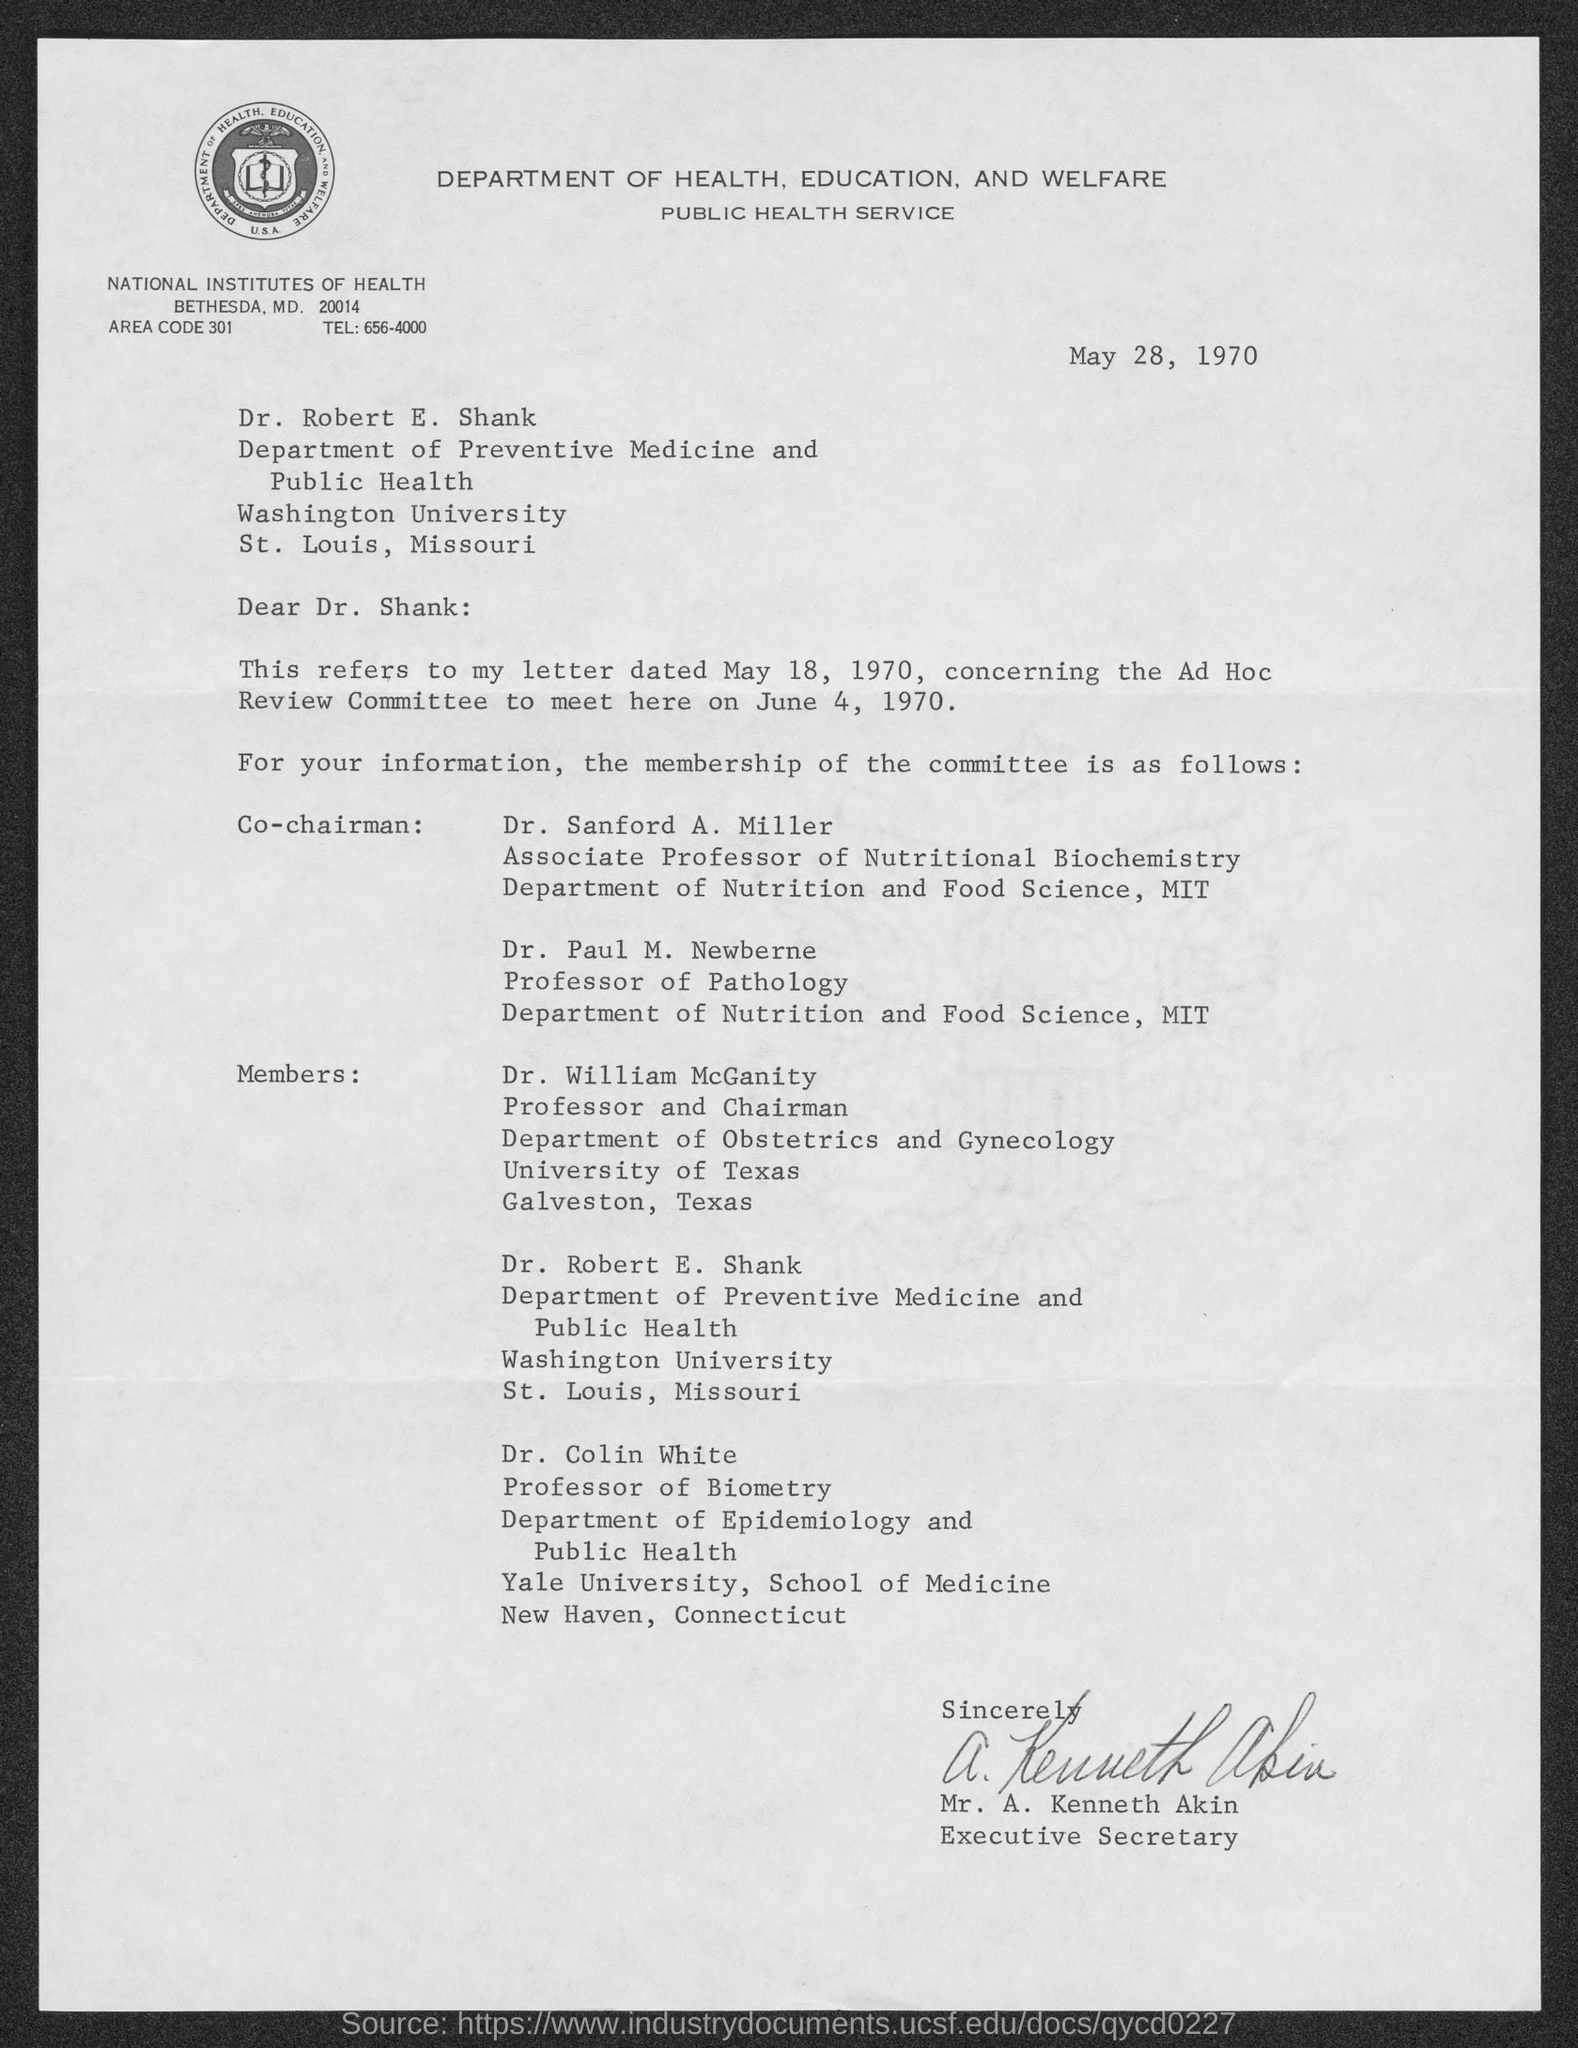What is the date on the document?
Your answer should be compact. May 28, 1970. To Whom is this letter addressed to?
Your answer should be very brief. Dr. Robert E. Shank. What does this letter refer to?
Provide a short and direct response. Letter dated may 18, 1970. When is the Ad Hoc Meeting Review Committee?
Your response must be concise. June 4, 1970. What is the Tel: for National Institutes of Health?
Your answer should be compact. 656-4000. Who is this letter from?
Your answer should be very brief. Mr. A. Kenneth Akin. 